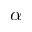Convert formula to latex. <formula><loc_0><loc_0><loc_500><loc_500>\alpha</formula> 